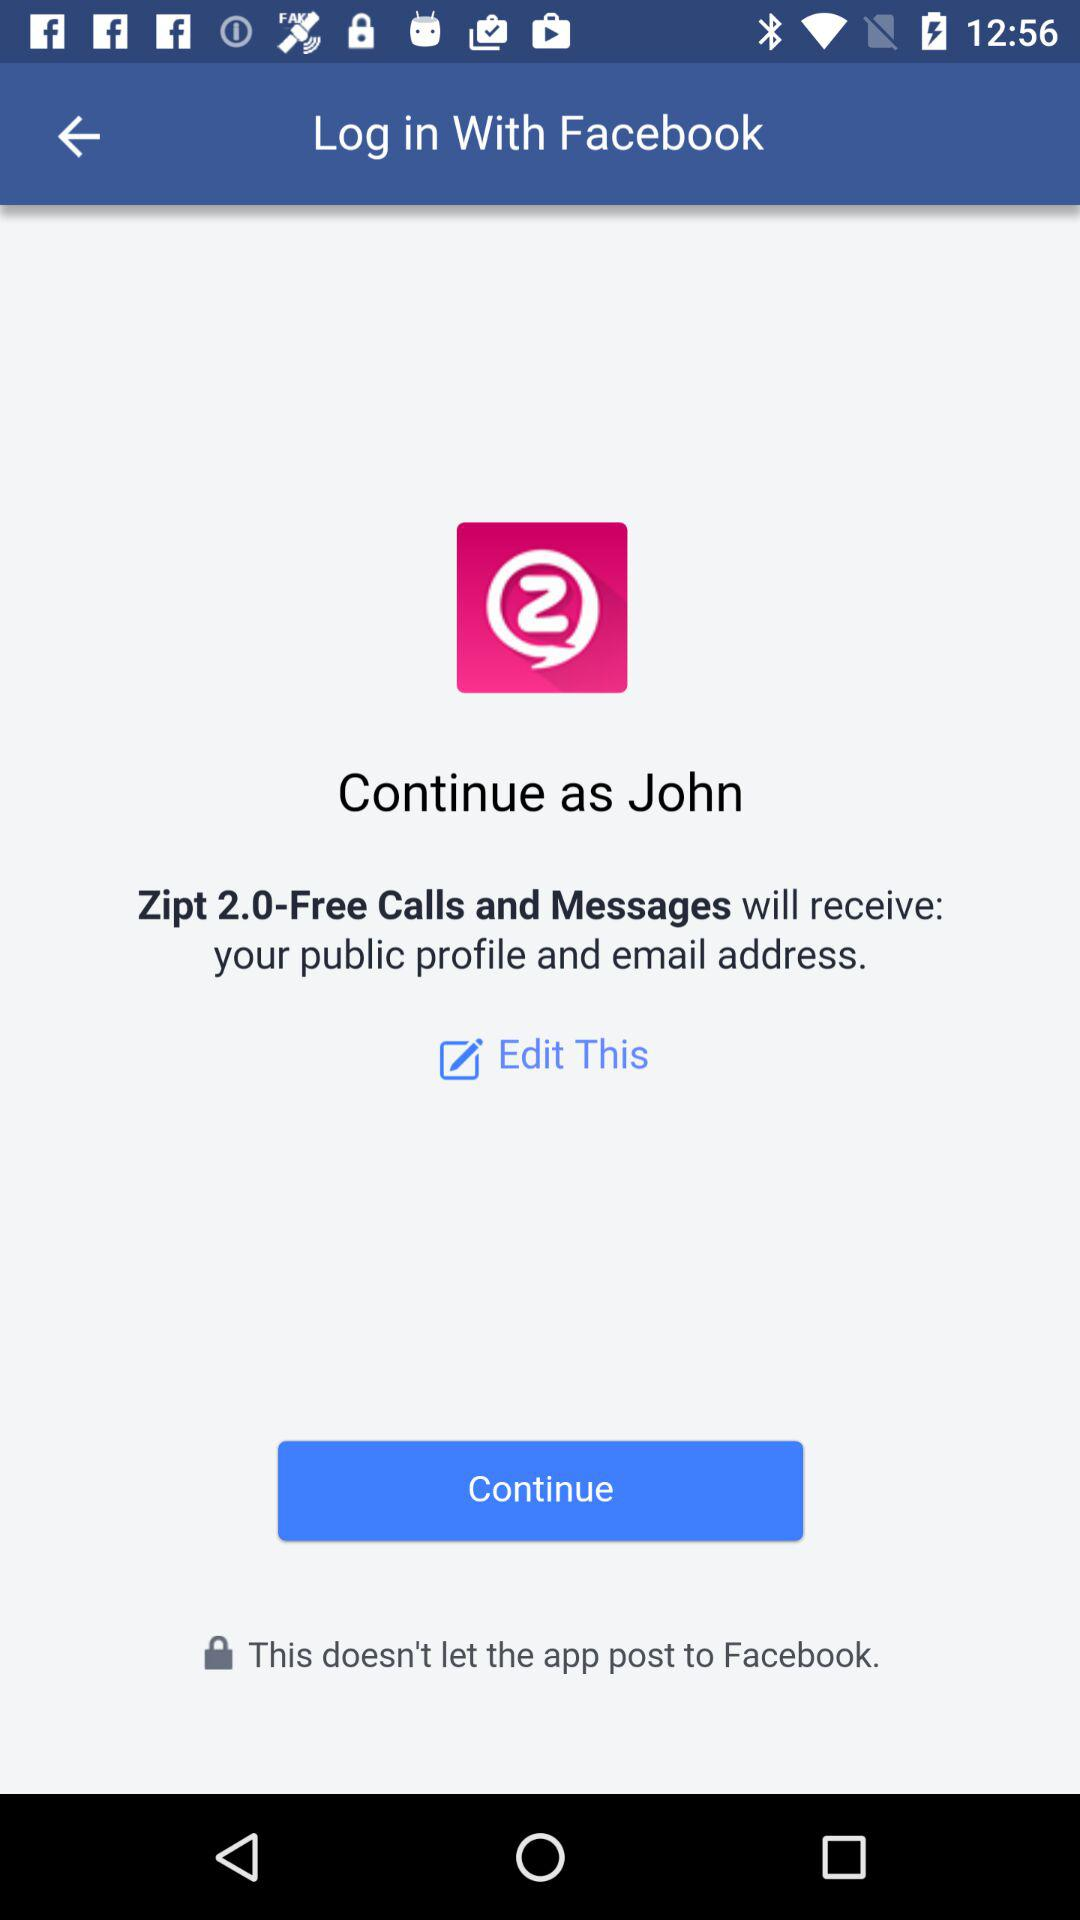What is the name of the user? The name of the user is John. 